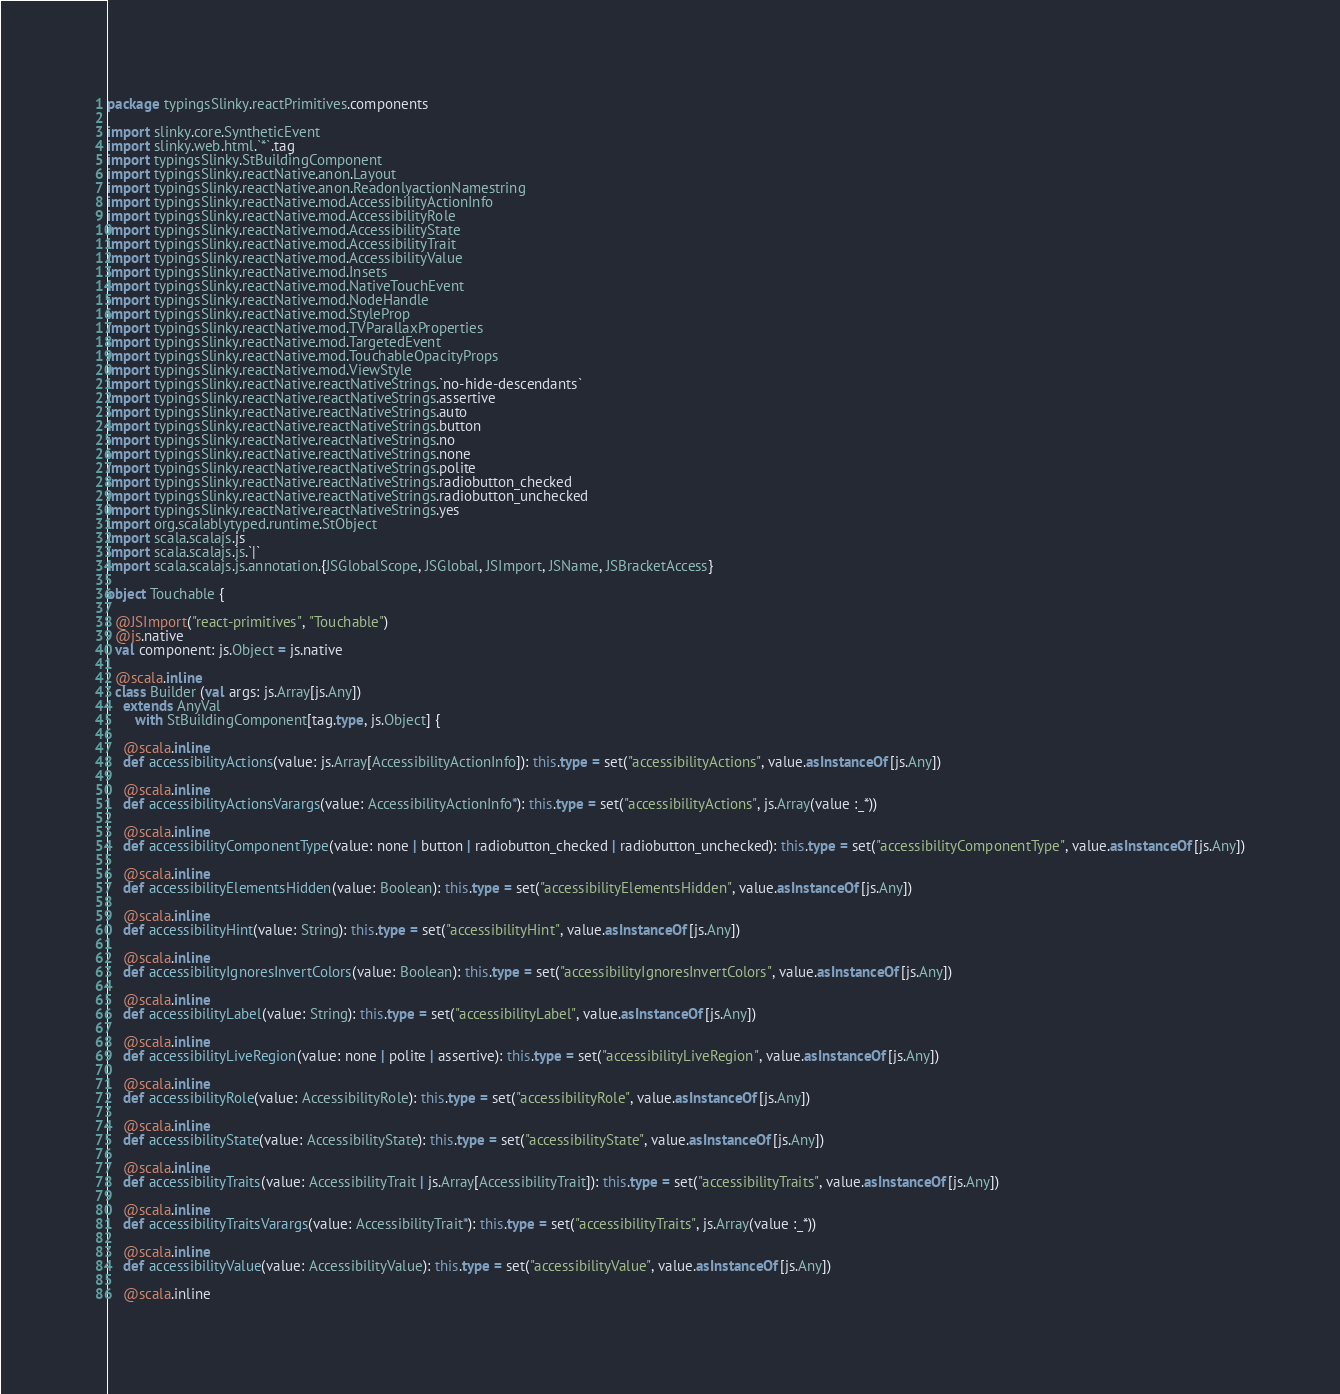Convert code to text. <code><loc_0><loc_0><loc_500><loc_500><_Scala_>package typingsSlinky.reactPrimitives.components

import slinky.core.SyntheticEvent
import slinky.web.html.`*`.tag
import typingsSlinky.StBuildingComponent
import typingsSlinky.reactNative.anon.Layout
import typingsSlinky.reactNative.anon.ReadonlyactionNamestring
import typingsSlinky.reactNative.mod.AccessibilityActionInfo
import typingsSlinky.reactNative.mod.AccessibilityRole
import typingsSlinky.reactNative.mod.AccessibilityState
import typingsSlinky.reactNative.mod.AccessibilityTrait
import typingsSlinky.reactNative.mod.AccessibilityValue
import typingsSlinky.reactNative.mod.Insets
import typingsSlinky.reactNative.mod.NativeTouchEvent
import typingsSlinky.reactNative.mod.NodeHandle
import typingsSlinky.reactNative.mod.StyleProp
import typingsSlinky.reactNative.mod.TVParallaxProperties
import typingsSlinky.reactNative.mod.TargetedEvent
import typingsSlinky.reactNative.mod.TouchableOpacityProps
import typingsSlinky.reactNative.mod.ViewStyle
import typingsSlinky.reactNative.reactNativeStrings.`no-hide-descendants`
import typingsSlinky.reactNative.reactNativeStrings.assertive
import typingsSlinky.reactNative.reactNativeStrings.auto
import typingsSlinky.reactNative.reactNativeStrings.button
import typingsSlinky.reactNative.reactNativeStrings.no
import typingsSlinky.reactNative.reactNativeStrings.none
import typingsSlinky.reactNative.reactNativeStrings.polite
import typingsSlinky.reactNative.reactNativeStrings.radiobutton_checked
import typingsSlinky.reactNative.reactNativeStrings.radiobutton_unchecked
import typingsSlinky.reactNative.reactNativeStrings.yes
import org.scalablytyped.runtime.StObject
import scala.scalajs.js
import scala.scalajs.js.`|`
import scala.scalajs.js.annotation.{JSGlobalScope, JSGlobal, JSImport, JSName, JSBracketAccess}

object Touchable {
  
  @JSImport("react-primitives", "Touchable")
  @js.native
  val component: js.Object = js.native
  
  @scala.inline
  class Builder (val args: js.Array[js.Any])
    extends AnyVal
       with StBuildingComponent[tag.type, js.Object] {
    
    @scala.inline
    def accessibilityActions(value: js.Array[AccessibilityActionInfo]): this.type = set("accessibilityActions", value.asInstanceOf[js.Any])
    
    @scala.inline
    def accessibilityActionsVarargs(value: AccessibilityActionInfo*): this.type = set("accessibilityActions", js.Array(value :_*))
    
    @scala.inline
    def accessibilityComponentType(value: none | button | radiobutton_checked | radiobutton_unchecked): this.type = set("accessibilityComponentType", value.asInstanceOf[js.Any])
    
    @scala.inline
    def accessibilityElementsHidden(value: Boolean): this.type = set("accessibilityElementsHidden", value.asInstanceOf[js.Any])
    
    @scala.inline
    def accessibilityHint(value: String): this.type = set("accessibilityHint", value.asInstanceOf[js.Any])
    
    @scala.inline
    def accessibilityIgnoresInvertColors(value: Boolean): this.type = set("accessibilityIgnoresInvertColors", value.asInstanceOf[js.Any])
    
    @scala.inline
    def accessibilityLabel(value: String): this.type = set("accessibilityLabel", value.asInstanceOf[js.Any])
    
    @scala.inline
    def accessibilityLiveRegion(value: none | polite | assertive): this.type = set("accessibilityLiveRegion", value.asInstanceOf[js.Any])
    
    @scala.inline
    def accessibilityRole(value: AccessibilityRole): this.type = set("accessibilityRole", value.asInstanceOf[js.Any])
    
    @scala.inline
    def accessibilityState(value: AccessibilityState): this.type = set("accessibilityState", value.asInstanceOf[js.Any])
    
    @scala.inline
    def accessibilityTraits(value: AccessibilityTrait | js.Array[AccessibilityTrait]): this.type = set("accessibilityTraits", value.asInstanceOf[js.Any])
    
    @scala.inline
    def accessibilityTraitsVarargs(value: AccessibilityTrait*): this.type = set("accessibilityTraits", js.Array(value :_*))
    
    @scala.inline
    def accessibilityValue(value: AccessibilityValue): this.type = set("accessibilityValue", value.asInstanceOf[js.Any])
    
    @scala.inline</code> 